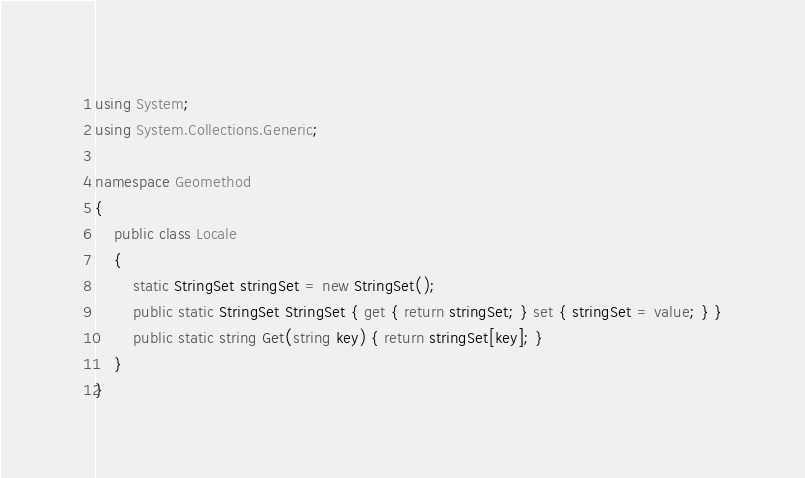Convert code to text. <code><loc_0><loc_0><loc_500><loc_500><_C#_>using System;
using System.Collections.Generic;

namespace Geomethod
{
	public class Locale
	{
		static StringSet stringSet = new StringSet();
		public static StringSet StringSet { get { return stringSet; } set { stringSet = value; } }
		public static string Get(string key) { return stringSet[key]; }
	}
}
</code> 